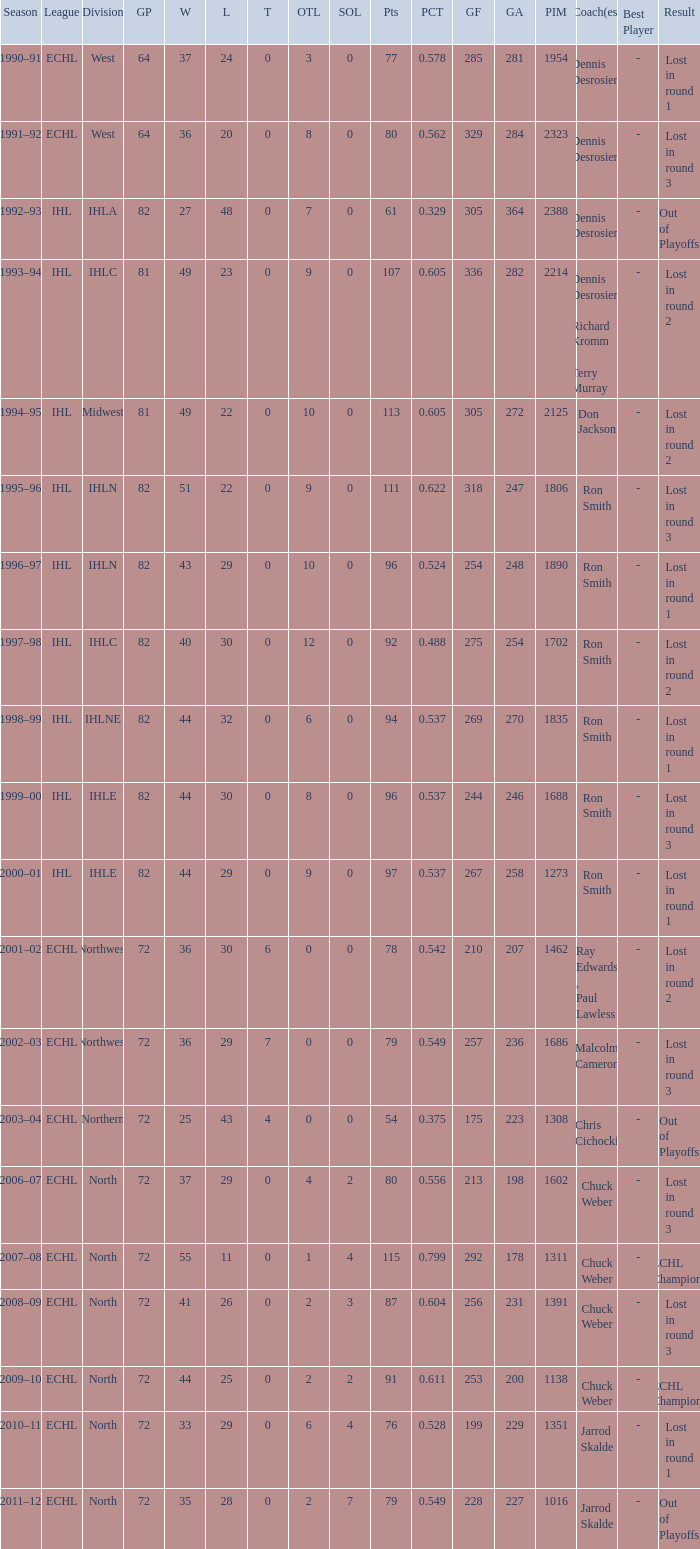How many season did the team lost in round 1 with a GP of 64? 1.0. 